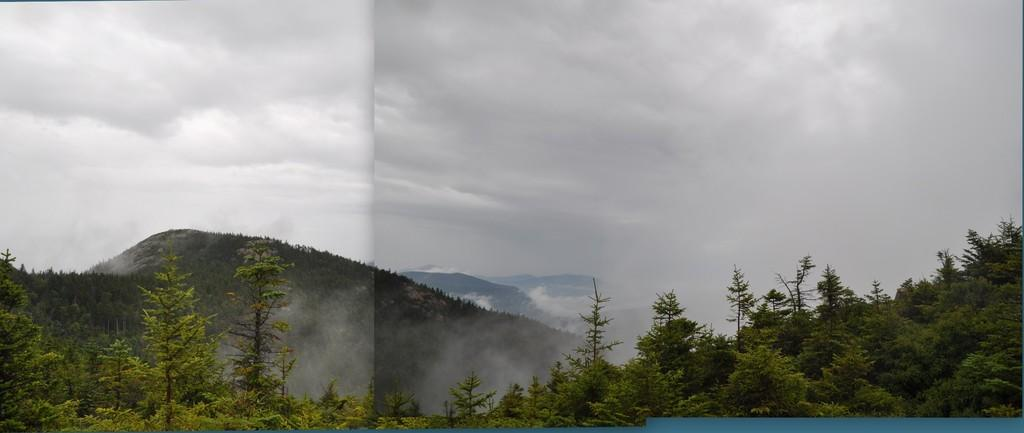What type of vegetation is present at the bottom side of the image? There are trees at the bottom side of the image. What geographical feature is located on the left side of the image? There is a mountain on the left side of the image. What part of the natural environment is visible at the top side of the image? There is sky at the top side of the image. What type of cheese can be seen on the mountain in the image? There is no cheese present in the image; it features trees, a mountain, and sky. How many trucks are visible on the mountain in the image? There are no trucks present in the image; it features trees, a mountain, and sky. 